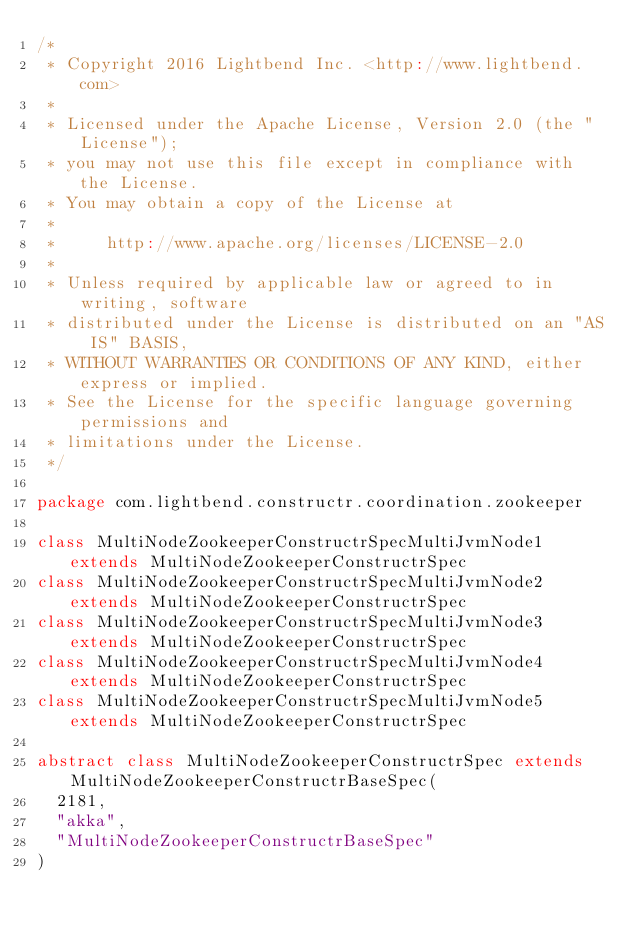Convert code to text. <code><loc_0><loc_0><loc_500><loc_500><_Scala_>/*
 * Copyright 2016 Lightbend Inc. <http://www.lightbend.com>
 *
 * Licensed under the Apache License, Version 2.0 (the "License");
 * you may not use this file except in compliance with the License.
 * You may obtain a copy of the License at
 *
 *     http://www.apache.org/licenses/LICENSE-2.0
 *
 * Unless required by applicable law or agreed to in writing, software
 * distributed under the License is distributed on an "AS IS" BASIS,
 * WITHOUT WARRANTIES OR CONDITIONS OF ANY KIND, either express or implied.
 * See the License for the specific language governing permissions and
 * limitations under the License.
 */

package com.lightbend.constructr.coordination.zookeeper

class MultiNodeZookeeperConstructrSpecMultiJvmNode1 extends MultiNodeZookeeperConstructrSpec
class MultiNodeZookeeperConstructrSpecMultiJvmNode2 extends MultiNodeZookeeperConstructrSpec
class MultiNodeZookeeperConstructrSpecMultiJvmNode3 extends MultiNodeZookeeperConstructrSpec
class MultiNodeZookeeperConstructrSpecMultiJvmNode4 extends MultiNodeZookeeperConstructrSpec
class MultiNodeZookeeperConstructrSpecMultiJvmNode5 extends MultiNodeZookeeperConstructrSpec

abstract class MultiNodeZookeeperConstructrSpec extends MultiNodeZookeeperConstructrBaseSpec(
  2181,
  "akka",
  "MultiNodeZookeeperConstructrBaseSpec"
)
</code> 